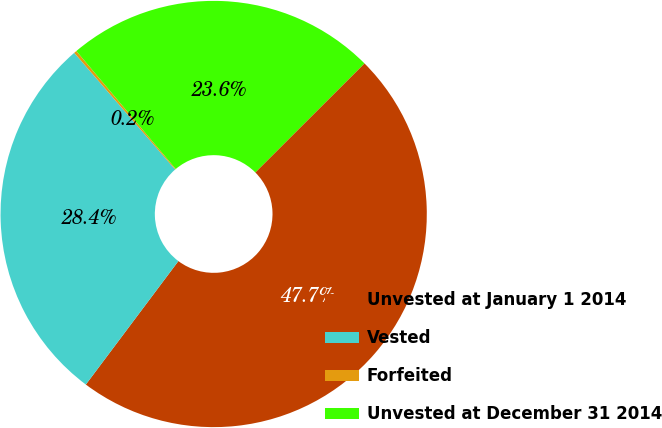Convert chart to OTSL. <chart><loc_0><loc_0><loc_500><loc_500><pie_chart><fcel>Unvested at January 1 2014<fcel>Vested<fcel>Forfeited<fcel>Unvested at December 31 2014<nl><fcel>47.73%<fcel>28.41%<fcel>0.21%<fcel>23.65%<nl></chart> 